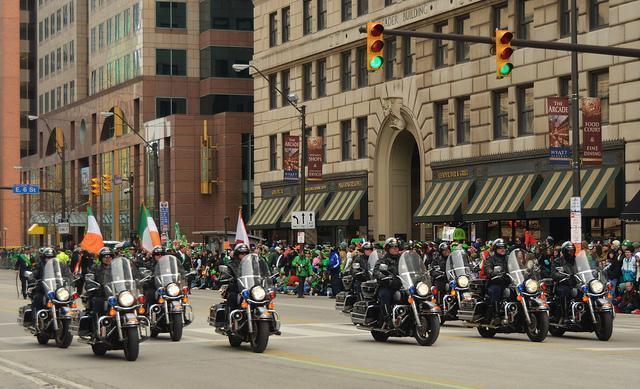Which nation is the motorcade of police motorcycles celebrating?
From the following set of four choices, select the accurate answer to respond to the question.
Options: Ireland, italy, ivory coast, mexico. Ireland. 